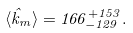Convert formula to latex. <formula><loc_0><loc_0><loc_500><loc_500>\langle \hat { k } _ { m } \rangle = 1 6 6 ^ { + 1 5 3 } _ { - 1 2 9 } .</formula> 